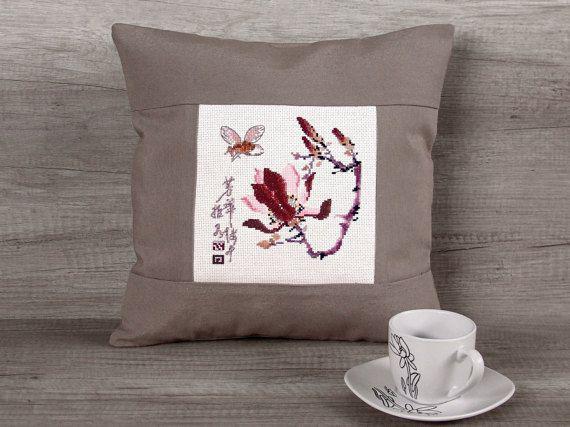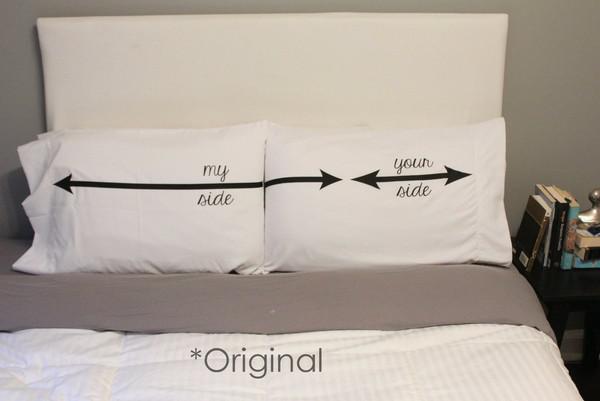The first image is the image on the left, the second image is the image on the right. Given the left and right images, does the statement "The left image includes a text-printed square pillow on a square wood stand, and the right image includes a pillow with a mammal depicted on it." hold true? Answer yes or no. No. 